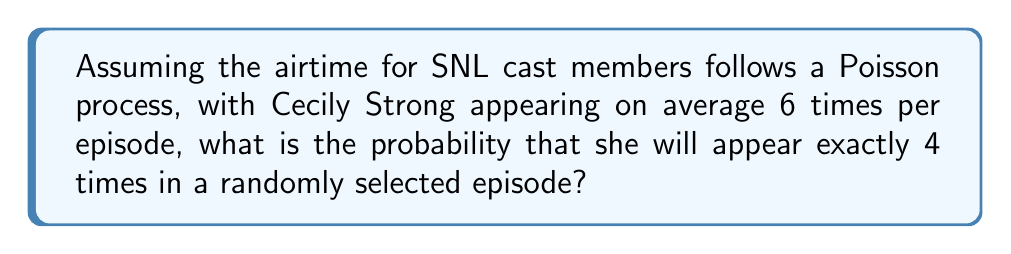Teach me how to tackle this problem. Let's approach this step-by-step:

1) In a Poisson process, the number of events (in this case, Cecily Strong's appearances) in a fixed interval follows a Poisson distribution.

2) The Poisson distribution is characterized by its rate parameter λ, which represents the average number of events per interval. Here, λ = 6.

3) The probability mass function for a Poisson distribution is:

   $$ P(X = k) = \frac{e^{-\lambda}\lambda^k}{k!} $$

   Where:
   - e is Euler's number (approximately 2.71828)
   - λ is the rate parameter
   - k is the number of events we're interested in

4) We want to find P(X = 4), so we plug in our values:

   $$ P(X = 4) = \frac{e^{-6}6^4}{4!} $$

5) Let's calculate this step-by-step:
   
   a) $6^4 = 1296$
   
   b) $4! = 4 \times 3 \times 2 \times 1 = 24$
   
   c) $e^{-6} \approx 0.00247875$

6) Putting it all together:

   $$ P(X = 4) = \frac{0.00247875 \times 1296}{24} \approx 0.1338 $$

Thus, the probability is approximately 0.1338 or 13.38%.
Answer: 0.1338 